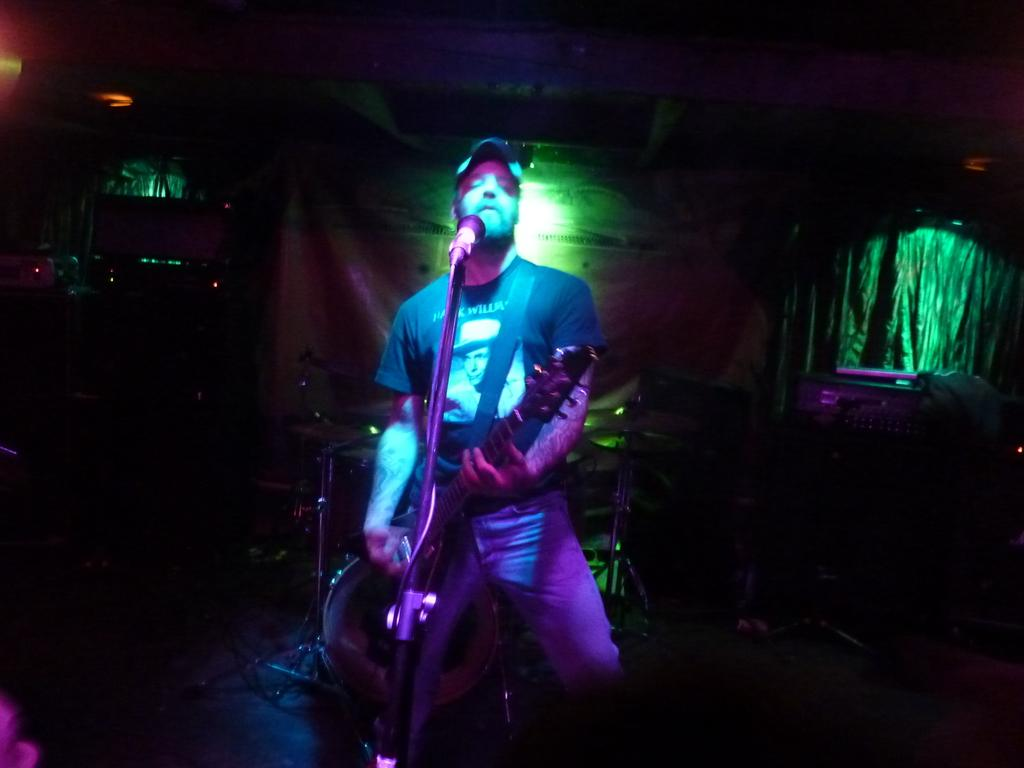What is the man in the image doing? The man is playing an instrument and singing into a microphone. How is the man positioned in the image? The man is standing. What can be seen in the background of the image? There are lights, drums, and curtains visible in the background. What type of muscle development can be seen in the man's arms in the image? There is no information about the man's muscle development in the image, as it focuses on his actions and the background. 